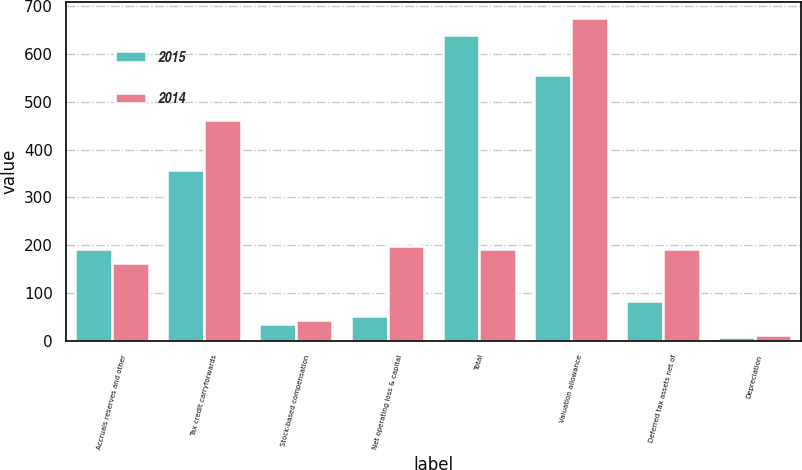Convert chart to OTSL. <chart><loc_0><loc_0><loc_500><loc_500><stacked_bar_chart><ecel><fcel>Accruals reserves and other<fcel>Tax credit carryforwards<fcel>Stock-based compensation<fcel>Net operating loss & capital<fcel>Total<fcel>Valuation allowance<fcel>Deferred tax assets net of<fcel>Depreciation<nl><fcel>2015<fcel>193<fcel>358<fcel>35<fcel>53<fcel>639<fcel>555<fcel>84<fcel>9<nl><fcel>2014<fcel>163<fcel>462<fcel>43<fcel>199<fcel>192<fcel>675<fcel>192<fcel>12<nl></chart> 